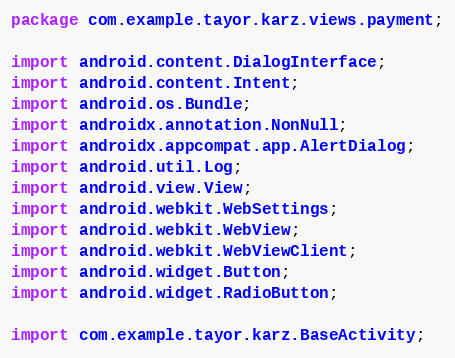Convert code to text. <code><loc_0><loc_0><loc_500><loc_500><_Java_>package com.example.tayor.karz.views.payment;

import android.content.DialogInterface;
import android.content.Intent;
import android.os.Bundle;
import androidx.annotation.NonNull;
import androidx.appcompat.app.AlertDialog;
import android.util.Log;
import android.view.View;
import android.webkit.WebSettings;
import android.webkit.WebView;
import android.webkit.WebViewClient;
import android.widget.Button;
import android.widget.RadioButton;

import com.example.tayor.karz.BaseActivity;</code> 